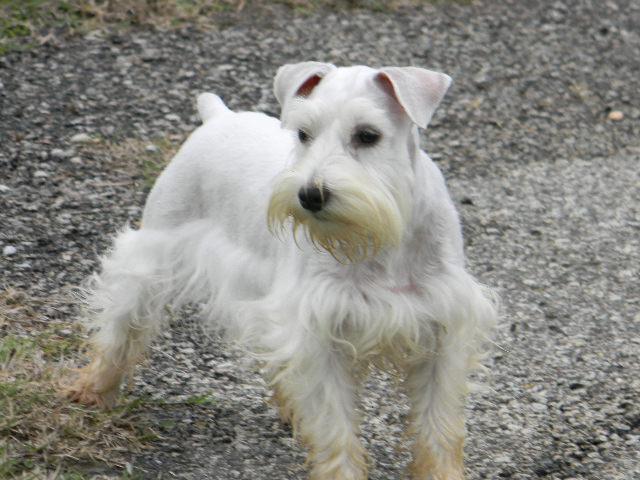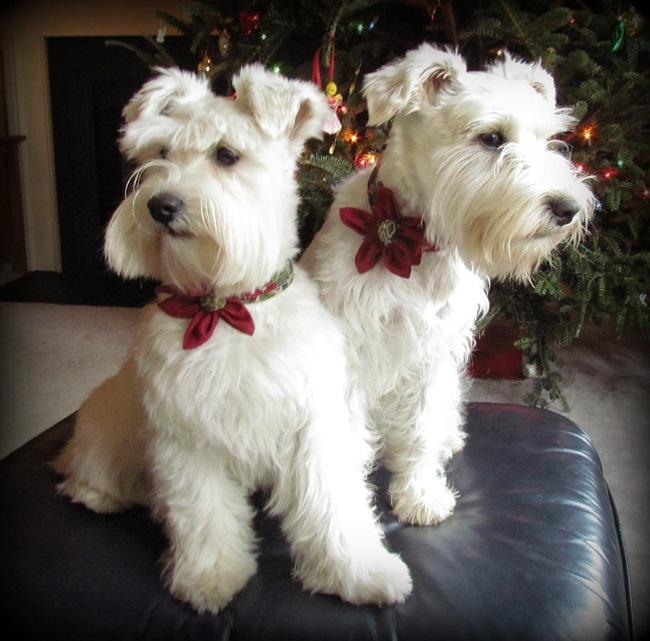The first image is the image on the left, the second image is the image on the right. Considering the images on both sides, is "One puppy is sitting on tile flooring." valid? Answer yes or no. No. The first image is the image on the left, the second image is the image on the right. Evaluate the accuracy of this statement regarding the images: "a single dog is sitting on a tile floor". Is it true? Answer yes or no. No. 